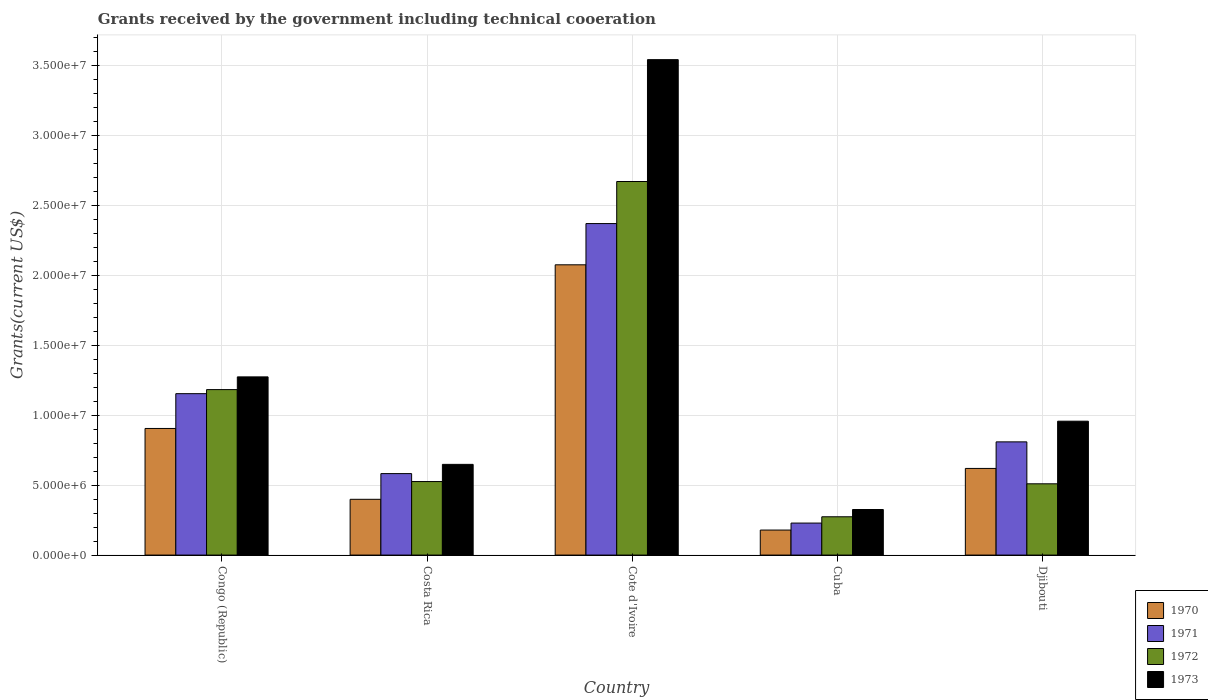How many different coloured bars are there?
Your answer should be very brief. 4. What is the label of the 3rd group of bars from the left?
Provide a succinct answer. Cote d'Ivoire. In how many cases, is the number of bars for a given country not equal to the number of legend labels?
Your response must be concise. 0. What is the total grants received by the government in 1970 in Congo (Republic)?
Provide a short and direct response. 9.06e+06. Across all countries, what is the maximum total grants received by the government in 1972?
Offer a terse response. 2.67e+07. Across all countries, what is the minimum total grants received by the government in 1973?
Offer a very short reply. 3.26e+06. In which country was the total grants received by the government in 1972 maximum?
Ensure brevity in your answer.  Cote d'Ivoire. In which country was the total grants received by the government in 1971 minimum?
Offer a terse response. Cuba. What is the total total grants received by the government in 1972 in the graph?
Keep it short and to the point. 5.17e+07. What is the difference between the total grants received by the government in 1972 in Cote d'Ivoire and that in Djibouti?
Ensure brevity in your answer.  2.16e+07. What is the difference between the total grants received by the government in 1970 in Congo (Republic) and the total grants received by the government in 1972 in Cuba?
Provide a short and direct response. 6.32e+06. What is the average total grants received by the government in 1970 per country?
Your answer should be very brief. 8.36e+06. What is the difference between the total grants received by the government of/in 1970 and total grants received by the government of/in 1972 in Congo (Republic)?
Your response must be concise. -2.78e+06. In how many countries, is the total grants received by the government in 1971 greater than 6000000 US$?
Ensure brevity in your answer.  3. What is the ratio of the total grants received by the government in 1972 in Congo (Republic) to that in Cote d'Ivoire?
Keep it short and to the point. 0.44. Is the total grants received by the government in 1972 in Cuba less than that in Djibouti?
Keep it short and to the point. Yes. Is the difference between the total grants received by the government in 1970 in Cuba and Djibouti greater than the difference between the total grants received by the government in 1972 in Cuba and Djibouti?
Provide a short and direct response. No. What is the difference between the highest and the second highest total grants received by the government in 1970?
Offer a very short reply. 1.17e+07. What is the difference between the highest and the lowest total grants received by the government in 1973?
Keep it short and to the point. 3.22e+07. Is the sum of the total grants received by the government in 1972 in Congo (Republic) and Djibouti greater than the maximum total grants received by the government in 1971 across all countries?
Make the answer very short. No. What does the 3rd bar from the left in Congo (Republic) represents?
Give a very brief answer. 1972. What does the 4th bar from the right in Cote d'Ivoire represents?
Your answer should be compact. 1970. What is the difference between two consecutive major ticks on the Y-axis?
Provide a short and direct response. 5.00e+06. Does the graph contain grids?
Offer a very short reply. Yes. What is the title of the graph?
Make the answer very short. Grants received by the government including technical cooeration. Does "1990" appear as one of the legend labels in the graph?
Provide a short and direct response. No. What is the label or title of the Y-axis?
Your answer should be compact. Grants(current US$). What is the Grants(current US$) of 1970 in Congo (Republic)?
Provide a succinct answer. 9.06e+06. What is the Grants(current US$) of 1971 in Congo (Republic)?
Your answer should be very brief. 1.16e+07. What is the Grants(current US$) of 1972 in Congo (Republic)?
Provide a succinct answer. 1.18e+07. What is the Grants(current US$) of 1973 in Congo (Republic)?
Your answer should be very brief. 1.28e+07. What is the Grants(current US$) of 1970 in Costa Rica?
Make the answer very short. 3.99e+06. What is the Grants(current US$) of 1971 in Costa Rica?
Provide a short and direct response. 5.83e+06. What is the Grants(current US$) of 1972 in Costa Rica?
Provide a short and direct response. 5.26e+06. What is the Grants(current US$) of 1973 in Costa Rica?
Make the answer very short. 6.49e+06. What is the Grants(current US$) in 1970 in Cote d'Ivoire?
Make the answer very short. 2.08e+07. What is the Grants(current US$) of 1971 in Cote d'Ivoire?
Offer a very short reply. 2.37e+07. What is the Grants(current US$) of 1972 in Cote d'Ivoire?
Ensure brevity in your answer.  2.67e+07. What is the Grants(current US$) of 1973 in Cote d'Ivoire?
Provide a short and direct response. 3.54e+07. What is the Grants(current US$) of 1970 in Cuba?
Ensure brevity in your answer.  1.79e+06. What is the Grants(current US$) in 1971 in Cuba?
Your answer should be compact. 2.29e+06. What is the Grants(current US$) of 1972 in Cuba?
Make the answer very short. 2.74e+06. What is the Grants(current US$) of 1973 in Cuba?
Give a very brief answer. 3.26e+06. What is the Grants(current US$) in 1970 in Djibouti?
Provide a short and direct response. 6.20e+06. What is the Grants(current US$) of 1971 in Djibouti?
Provide a short and direct response. 8.10e+06. What is the Grants(current US$) of 1972 in Djibouti?
Offer a terse response. 5.10e+06. What is the Grants(current US$) in 1973 in Djibouti?
Offer a terse response. 9.58e+06. Across all countries, what is the maximum Grants(current US$) of 1970?
Offer a very short reply. 2.08e+07. Across all countries, what is the maximum Grants(current US$) in 1971?
Keep it short and to the point. 2.37e+07. Across all countries, what is the maximum Grants(current US$) in 1972?
Make the answer very short. 2.67e+07. Across all countries, what is the maximum Grants(current US$) in 1973?
Give a very brief answer. 3.54e+07. Across all countries, what is the minimum Grants(current US$) in 1970?
Offer a very short reply. 1.79e+06. Across all countries, what is the minimum Grants(current US$) in 1971?
Offer a terse response. 2.29e+06. Across all countries, what is the minimum Grants(current US$) in 1972?
Your answer should be compact. 2.74e+06. Across all countries, what is the minimum Grants(current US$) in 1973?
Your response must be concise. 3.26e+06. What is the total Grants(current US$) of 1970 in the graph?
Give a very brief answer. 4.18e+07. What is the total Grants(current US$) of 1971 in the graph?
Your answer should be compact. 5.15e+07. What is the total Grants(current US$) of 1972 in the graph?
Make the answer very short. 5.17e+07. What is the total Grants(current US$) of 1973 in the graph?
Offer a terse response. 6.75e+07. What is the difference between the Grants(current US$) in 1970 in Congo (Republic) and that in Costa Rica?
Provide a succinct answer. 5.07e+06. What is the difference between the Grants(current US$) of 1971 in Congo (Republic) and that in Costa Rica?
Provide a succinct answer. 5.72e+06. What is the difference between the Grants(current US$) in 1972 in Congo (Republic) and that in Costa Rica?
Your answer should be very brief. 6.58e+06. What is the difference between the Grants(current US$) of 1973 in Congo (Republic) and that in Costa Rica?
Your answer should be very brief. 6.26e+06. What is the difference between the Grants(current US$) of 1970 in Congo (Republic) and that in Cote d'Ivoire?
Offer a terse response. -1.17e+07. What is the difference between the Grants(current US$) in 1971 in Congo (Republic) and that in Cote d'Ivoire?
Ensure brevity in your answer.  -1.22e+07. What is the difference between the Grants(current US$) in 1972 in Congo (Republic) and that in Cote d'Ivoire?
Provide a short and direct response. -1.49e+07. What is the difference between the Grants(current US$) of 1973 in Congo (Republic) and that in Cote d'Ivoire?
Your answer should be very brief. -2.27e+07. What is the difference between the Grants(current US$) in 1970 in Congo (Republic) and that in Cuba?
Make the answer very short. 7.27e+06. What is the difference between the Grants(current US$) in 1971 in Congo (Republic) and that in Cuba?
Make the answer very short. 9.26e+06. What is the difference between the Grants(current US$) of 1972 in Congo (Republic) and that in Cuba?
Provide a short and direct response. 9.10e+06. What is the difference between the Grants(current US$) of 1973 in Congo (Republic) and that in Cuba?
Make the answer very short. 9.49e+06. What is the difference between the Grants(current US$) of 1970 in Congo (Republic) and that in Djibouti?
Keep it short and to the point. 2.86e+06. What is the difference between the Grants(current US$) in 1971 in Congo (Republic) and that in Djibouti?
Your answer should be compact. 3.45e+06. What is the difference between the Grants(current US$) of 1972 in Congo (Republic) and that in Djibouti?
Your answer should be very brief. 6.74e+06. What is the difference between the Grants(current US$) in 1973 in Congo (Republic) and that in Djibouti?
Your answer should be compact. 3.17e+06. What is the difference between the Grants(current US$) of 1970 in Costa Rica and that in Cote d'Ivoire?
Offer a very short reply. -1.68e+07. What is the difference between the Grants(current US$) in 1971 in Costa Rica and that in Cote d'Ivoire?
Your answer should be compact. -1.79e+07. What is the difference between the Grants(current US$) of 1972 in Costa Rica and that in Cote d'Ivoire?
Provide a short and direct response. -2.15e+07. What is the difference between the Grants(current US$) in 1973 in Costa Rica and that in Cote d'Ivoire?
Your answer should be very brief. -2.90e+07. What is the difference between the Grants(current US$) of 1970 in Costa Rica and that in Cuba?
Your answer should be very brief. 2.20e+06. What is the difference between the Grants(current US$) of 1971 in Costa Rica and that in Cuba?
Your response must be concise. 3.54e+06. What is the difference between the Grants(current US$) of 1972 in Costa Rica and that in Cuba?
Make the answer very short. 2.52e+06. What is the difference between the Grants(current US$) of 1973 in Costa Rica and that in Cuba?
Keep it short and to the point. 3.23e+06. What is the difference between the Grants(current US$) in 1970 in Costa Rica and that in Djibouti?
Give a very brief answer. -2.21e+06. What is the difference between the Grants(current US$) of 1971 in Costa Rica and that in Djibouti?
Your response must be concise. -2.27e+06. What is the difference between the Grants(current US$) in 1973 in Costa Rica and that in Djibouti?
Make the answer very short. -3.09e+06. What is the difference between the Grants(current US$) in 1970 in Cote d'Ivoire and that in Cuba?
Provide a short and direct response. 1.90e+07. What is the difference between the Grants(current US$) of 1971 in Cote d'Ivoire and that in Cuba?
Give a very brief answer. 2.14e+07. What is the difference between the Grants(current US$) in 1972 in Cote d'Ivoire and that in Cuba?
Your response must be concise. 2.40e+07. What is the difference between the Grants(current US$) in 1973 in Cote d'Ivoire and that in Cuba?
Your answer should be very brief. 3.22e+07. What is the difference between the Grants(current US$) of 1970 in Cote d'Ivoire and that in Djibouti?
Give a very brief answer. 1.46e+07. What is the difference between the Grants(current US$) in 1971 in Cote d'Ivoire and that in Djibouti?
Ensure brevity in your answer.  1.56e+07. What is the difference between the Grants(current US$) of 1972 in Cote d'Ivoire and that in Djibouti?
Offer a terse response. 2.16e+07. What is the difference between the Grants(current US$) of 1973 in Cote d'Ivoire and that in Djibouti?
Offer a very short reply. 2.59e+07. What is the difference between the Grants(current US$) of 1970 in Cuba and that in Djibouti?
Keep it short and to the point. -4.41e+06. What is the difference between the Grants(current US$) in 1971 in Cuba and that in Djibouti?
Make the answer very short. -5.81e+06. What is the difference between the Grants(current US$) in 1972 in Cuba and that in Djibouti?
Keep it short and to the point. -2.36e+06. What is the difference between the Grants(current US$) of 1973 in Cuba and that in Djibouti?
Give a very brief answer. -6.32e+06. What is the difference between the Grants(current US$) in 1970 in Congo (Republic) and the Grants(current US$) in 1971 in Costa Rica?
Your answer should be very brief. 3.23e+06. What is the difference between the Grants(current US$) of 1970 in Congo (Republic) and the Grants(current US$) of 1972 in Costa Rica?
Your response must be concise. 3.80e+06. What is the difference between the Grants(current US$) of 1970 in Congo (Republic) and the Grants(current US$) of 1973 in Costa Rica?
Make the answer very short. 2.57e+06. What is the difference between the Grants(current US$) of 1971 in Congo (Republic) and the Grants(current US$) of 1972 in Costa Rica?
Provide a succinct answer. 6.29e+06. What is the difference between the Grants(current US$) of 1971 in Congo (Republic) and the Grants(current US$) of 1973 in Costa Rica?
Offer a terse response. 5.06e+06. What is the difference between the Grants(current US$) of 1972 in Congo (Republic) and the Grants(current US$) of 1973 in Costa Rica?
Your answer should be very brief. 5.35e+06. What is the difference between the Grants(current US$) in 1970 in Congo (Republic) and the Grants(current US$) in 1971 in Cote d'Ivoire?
Make the answer very short. -1.47e+07. What is the difference between the Grants(current US$) of 1970 in Congo (Republic) and the Grants(current US$) of 1972 in Cote d'Ivoire?
Offer a terse response. -1.77e+07. What is the difference between the Grants(current US$) in 1970 in Congo (Republic) and the Grants(current US$) in 1973 in Cote d'Ivoire?
Keep it short and to the point. -2.64e+07. What is the difference between the Grants(current US$) in 1971 in Congo (Republic) and the Grants(current US$) in 1972 in Cote d'Ivoire?
Ensure brevity in your answer.  -1.52e+07. What is the difference between the Grants(current US$) in 1971 in Congo (Republic) and the Grants(current US$) in 1973 in Cote d'Ivoire?
Your answer should be compact. -2.39e+07. What is the difference between the Grants(current US$) of 1972 in Congo (Republic) and the Grants(current US$) of 1973 in Cote d'Ivoire?
Your response must be concise. -2.36e+07. What is the difference between the Grants(current US$) of 1970 in Congo (Republic) and the Grants(current US$) of 1971 in Cuba?
Provide a short and direct response. 6.77e+06. What is the difference between the Grants(current US$) of 1970 in Congo (Republic) and the Grants(current US$) of 1972 in Cuba?
Your answer should be very brief. 6.32e+06. What is the difference between the Grants(current US$) of 1970 in Congo (Republic) and the Grants(current US$) of 1973 in Cuba?
Make the answer very short. 5.80e+06. What is the difference between the Grants(current US$) of 1971 in Congo (Republic) and the Grants(current US$) of 1972 in Cuba?
Offer a terse response. 8.81e+06. What is the difference between the Grants(current US$) of 1971 in Congo (Republic) and the Grants(current US$) of 1973 in Cuba?
Make the answer very short. 8.29e+06. What is the difference between the Grants(current US$) in 1972 in Congo (Republic) and the Grants(current US$) in 1973 in Cuba?
Your answer should be compact. 8.58e+06. What is the difference between the Grants(current US$) in 1970 in Congo (Republic) and the Grants(current US$) in 1971 in Djibouti?
Give a very brief answer. 9.60e+05. What is the difference between the Grants(current US$) of 1970 in Congo (Republic) and the Grants(current US$) of 1972 in Djibouti?
Your answer should be compact. 3.96e+06. What is the difference between the Grants(current US$) in 1970 in Congo (Republic) and the Grants(current US$) in 1973 in Djibouti?
Your answer should be compact. -5.20e+05. What is the difference between the Grants(current US$) in 1971 in Congo (Republic) and the Grants(current US$) in 1972 in Djibouti?
Provide a succinct answer. 6.45e+06. What is the difference between the Grants(current US$) of 1971 in Congo (Republic) and the Grants(current US$) of 1973 in Djibouti?
Give a very brief answer. 1.97e+06. What is the difference between the Grants(current US$) in 1972 in Congo (Republic) and the Grants(current US$) in 1973 in Djibouti?
Your answer should be very brief. 2.26e+06. What is the difference between the Grants(current US$) in 1970 in Costa Rica and the Grants(current US$) in 1971 in Cote d'Ivoire?
Ensure brevity in your answer.  -1.97e+07. What is the difference between the Grants(current US$) of 1970 in Costa Rica and the Grants(current US$) of 1972 in Cote d'Ivoire?
Offer a very short reply. -2.27e+07. What is the difference between the Grants(current US$) in 1970 in Costa Rica and the Grants(current US$) in 1973 in Cote d'Ivoire?
Provide a short and direct response. -3.15e+07. What is the difference between the Grants(current US$) in 1971 in Costa Rica and the Grants(current US$) in 1972 in Cote d'Ivoire?
Provide a succinct answer. -2.09e+07. What is the difference between the Grants(current US$) of 1971 in Costa Rica and the Grants(current US$) of 1973 in Cote d'Ivoire?
Your response must be concise. -2.96e+07. What is the difference between the Grants(current US$) in 1972 in Costa Rica and the Grants(current US$) in 1973 in Cote d'Ivoire?
Provide a succinct answer. -3.02e+07. What is the difference between the Grants(current US$) in 1970 in Costa Rica and the Grants(current US$) in 1971 in Cuba?
Make the answer very short. 1.70e+06. What is the difference between the Grants(current US$) of 1970 in Costa Rica and the Grants(current US$) of 1972 in Cuba?
Your answer should be very brief. 1.25e+06. What is the difference between the Grants(current US$) in 1970 in Costa Rica and the Grants(current US$) in 1973 in Cuba?
Keep it short and to the point. 7.30e+05. What is the difference between the Grants(current US$) of 1971 in Costa Rica and the Grants(current US$) of 1972 in Cuba?
Your answer should be compact. 3.09e+06. What is the difference between the Grants(current US$) in 1971 in Costa Rica and the Grants(current US$) in 1973 in Cuba?
Your answer should be very brief. 2.57e+06. What is the difference between the Grants(current US$) of 1972 in Costa Rica and the Grants(current US$) of 1973 in Cuba?
Offer a terse response. 2.00e+06. What is the difference between the Grants(current US$) in 1970 in Costa Rica and the Grants(current US$) in 1971 in Djibouti?
Offer a terse response. -4.11e+06. What is the difference between the Grants(current US$) in 1970 in Costa Rica and the Grants(current US$) in 1972 in Djibouti?
Give a very brief answer. -1.11e+06. What is the difference between the Grants(current US$) in 1970 in Costa Rica and the Grants(current US$) in 1973 in Djibouti?
Offer a terse response. -5.59e+06. What is the difference between the Grants(current US$) of 1971 in Costa Rica and the Grants(current US$) of 1972 in Djibouti?
Ensure brevity in your answer.  7.30e+05. What is the difference between the Grants(current US$) in 1971 in Costa Rica and the Grants(current US$) in 1973 in Djibouti?
Give a very brief answer. -3.75e+06. What is the difference between the Grants(current US$) in 1972 in Costa Rica and the Grants(current US$) in 1973 in Djibouti?
Provide a succinct answer. -4.32e+06. What is the difference between the Grants(current US$) of 1970 in Cote d'Ivoire and the Grants(current US$) of 1971 in Cuba?
Provide a succinct answer. 1.85e+07. What is the difference between the Grants(current US$) in 1970 in Cote d'Ivoire and the Grants(current US$) in 1972 in Cuba?
Give a very brief answer. 1.80e+07. What is the difference between the Grants(current US$) in 1970 in Cote d'Ivoire and the Grants(current US$) in 1973 in Cuba?
Your answer should be very brief. 1.75e+07. What is the difference between the Grants(current US$) of 1971 in Cote d'Ivoire and the Grants(current US$) of 1972 in Cuba?
Offer a terse response. 2.10e+07. What is the difference between the Grants(current US$) of 1971 in Cote d'Ivoire and the Grants(current US$) of 1973 in Cuba?
Your answer should be very brief. 2.05e+07. What is the difference between the Grants(current US$) in 1972 in Cote d'Ivoire and the Grants(current US$) in 1973 in Cuba?
Provide a short and direct response. 2.35e+07. What is the difference between the Grants(current US$) in 1970 in Cote d'Ivoire and the Grants(current US$) in 1971 in Djibouti?
Make the answer very short. 1.27e+07. What is the difference between the Grants(current US$) of 1970 in Cote d'Ivoire and the Grants(current US$) of 1972 in Djibouti?
Your response must be concise. 1.57e+07. What is the difference between the Grants(current US$) in 1970 in Cote d'Ivoire and the Grants(current US$) in 1973 in Djibouti?
Keep it short and to the point. 1.12e+07. What is the difference between the Grants(current US$) of 1971 in Cote d'Ivoire and the Grants(current US$) of 1972 in Djibouti?
Offer a terse response. 1.86e+07. What is the difference between the Grants(current US$) of 1971 in Cote d'Ivoire and the Grants(current US$) of 1973 in Djibouti?
Provide a succinct answer. 1.41e+07. What is the difference between the Grants(current US$) of 1972 in Cote d'Ivoire and the Grants(current US$) of 1973 in Djibouti?
Keep it short and to the point. 1.72e+07. What is the difference between the Grants(current US$) of 1970 in Cuba and the Grants(current US$) of 1971 in Djibouti?
Keep it short and to the point. -6.31e+06. What is the difference between the Grants(current US$) of 1970 in Cuba and the Grants(current US$) of 1972 in Djibouti?
Make the answer very short. -3.31e+06. What is the difference between the Grants(current US$) of 1970 in Cuba and the Grants(current US$) of 1973 in Djibouti?
Offer a terse response. -7.79e+06. What is the difference between the Grants(current US$) in 1971 in Cuba and the Grants(current US$) in 1972 in Djibouti?
Your answer should be compact. -2.81e+06. What is the difference between the Grants(current US$) of 1971 in Cuba and the Grants(current US$) of 1973 in Djibouti?
Give a very brief answer. -7.29e+06. What is the difference between the Grants(current US$) of 1972 in Cuba and the Grants(current US$) of 1973 in Djibouti?
Your response must be concise. -6.84e+06. What is the average Grants(current US$) in 1970 per country?
Keep it short and to the point. 8.36e+06. What is the average Grants(current US$) of 1971 per country?
Offer a very short reply. 1.03e+07. What is the average Grants(current US$) in 1972 per country?
Provide a short and direct response. 1.03e+07. What is the average Grants(current US$) in 1973 per country?
Offer a very short reply. 1.35e+07. What is the difference between the Grants(current US$) in 1970 and Grants(current US$) in 1971 in Congo (Republic)?
Your response must be concise. -2.49e+06. What is the difference between the Grants(current US$) in 1970 and Grants(current US$) in 1972 in Congo (Republic)?
Make the answer very short. -2.78e+06. What is the difference between the Grants(current US$) of 1970 and Grants(current US$) of 1973 in Congo (Republic)?
Your answer should be very brief. -3.69e+06. What is the difference between the Grants(current US$) in 1971 and Grants(current US$) in 1973 in Congo (Republic)?
Provide a short and direct response. -1.20e+06. What is the difference between the Grants(current US$) in 1972 and Grants(current US$) in 1973 in Congo (Republic)?
Provide a succinct answer. -9.10e+05. What is the difference between the Grants(current US$) in 1970 and Grants(current US$) in 1971 in Costa Rica?
Offer a very short reply. -1.84e+06. What is the difference between the Grants(current US$) of 1970 and Grants(current US$) of 1972 in Costa Rica?
Keep it short and to the point. -1.27e+06. What is the difference between the Grants(current US$) of 1970 and Grants(current US$) of 1973 in Costa Rica?
Offer a terse response. -2.50e+06. What is the difference between the Grants(current US$) in 1971 and Grants(current US$) in 1972 in Costa Rica?
Keep it short and to the point. 5.70e+05. What is the difference between the Grants(current US$) of 1971 and Grants(current US$) of 1973 in Costa Rica?
Offer a very short reply. -6.60e+05. What is the difference between the Grants(current US$) in 1972 and Grants(current US$) in 1973 in Costa Rica?
Your answer should be very brief. -1.23e+06. What is the difference between the Grants(current US$) in 1970 and Grants(current US$) in 1971 in Cote d'Ivoire?
Your answer should be compact. -2.95e+06. What is the difference between the Grants(current US$) in 1970 and Grants(current US$) in 1972 in Cote d'Ivoire?
Offer a very short reply. -5.96e+06. What is the difference between the Grants(current US$) in 1970 and Grants(current US$) in 1973 in Cote d'Ivoire?
Make the answer very short. -1.47e+07. What is the difference between the Grants(current US$) in 1971 and Grants(current US$) in 1972 in Cote d'Ivoire?
Your answer should be compact. -3.01e+06. What is the difference between the Grants(current US$) of 1971 and Grants(current US$) of 1973 in Cote d'Ivoire?
Keep it short and to the point. -1.17e+07. What is the difference between the Grants(current US$) in 1972 and Grants(current US$) in 1973 in Cote d'Ivoire?
Your response must be concise. -8.72e+06. What is the difference between the Grants(current US$) in 1970 and Grants(current US$) in 1971 in Cuba?
Your response must be concise. -5.00e+05. What is the difference between the Grants(current US$) in 1970 and Grants(current US$) in 1972 in Cuba?
Provide a succinct answer. -9.50e+05. What is the difference between the Grants(current US$) in 1970 and Grants(current US$) in 1973 in Cuba?
Keep it short and to the point. -1.47e+06. What is the difference between the Grants(current US$) in 1971 and Grants(current US$) in 1972 in Cuba?
Make the answer very short. -4.50e+05. What is the difference between the Grants(current US$) in 1971 and Grants(current US$) in 1973 in Cuba?
Your response must be concise. -9.70e+05. What is the difference between the Grants(current US$) in 1972 and Grants(current US$) in 1973 in Cuba?
Offer a very short reply. -5.20e+05. What is the difference between the Grants(current US$) in 1970 and Grants(current US$) in 1971 in Djibouti?
Provide a succinct answer. -1.90e+06. What is the difference between the Grants(current US$) in 1970 and Grants(current US$) in 1972 in Djibouti?
Give a very brief answer. 1.10e+06. What is the difference between the Grants(current US$) in 1970 and Grants(current US$) in 1973 in Djibouti?
Your answer should be compact. -3.38e+06. What is the difference between the Grants(current US$) in 1971 and Grants(current US$) in 1972 in Djibouti?
Keep it short and to the point. 3.00e+06. What is the difference between the Grants(current US$) of 1971 and Grants(current US$) of 1973 in Djibouti?
Make the answer very short. -1.48e+06. What is the difference between the Grants(current US$) of 1972 and Grants(current US$) of 1973 in Djibouti?
Your response must be concise. -4.48e+06. What is the ratio of the Grants(current US$) of 1970 in Congo (Republic) to that in Costa Rica?
Keep it short and to the point. 2.27. What is the ratio of the Grants(current US$) of 1971 in Congo (Republic) to that in Costa Rica?
Your answer should be compact. 1.98. What is the ratio of the Grants(current US$) in 1972 in Congo (Republic) to that in Costa Rica?
Provide a short and direct response. 2.25. What is the ratio of the Grants(current US$) in 1973 in Congo (Republic) to that in Costa Rica?
Your answer should be very brief. 1.96. What is the ratio of the Grants(current US$) of 1970 in Congo (Republic) to that in Cote d'Ivoire?
Offer a terse response. 0.44. What is the ratio of the Grants(current US$) of 1971 in Congo (Republic) to that in Cote d'Ivoire?
Offer a terse response. 0.49. What is the ratio of the Grants(current US$) in 1972 in Congo (Republic) to that in Cote d'Ivoire?
Keep it short and to the point. 0.44. What is the ratio of the Grants(current US$) in 1973 in Congo (Republic) to that in Cote d'Ivoire?
Ensure brevity in your answer.  0.36. What is the ratio of the Grants(current US$) in 1970 in Congo (Republic) to that in Cuba?
Your answer should be very brief. 5.06. What is the ratio of the Grants(current US$) of 1971 in Congo (Republic) to that in Cuba?
Offer a terse response. 5.04. What is the ratio of the Grants(current US$) of 1972 in Congo (Republic) to that in Cuba?
Your response must be concise. 4.32. What is the ratio of the Grants(current US$) of 1973 in Congo (Republic) to that in Cuba?
Your answer should be compact. 3.91. What is the ratio of the Grants(current US$) in 1970 in Congo (Republic) to that in Djibouti?
Provide a short and direct response. 1.46. What is the ratio of the Grants(current US$) in 1971 in Congo (Republic) to that in Djibouti?
Your response must be concise. 1.43. What is the ratio of the Grants(current US$) in 1972 in Congo (Republic) to that in Djibouti?
Give a very brief answer. 2.32. What is the ratio of the Grants(current US$) in 1973 in Congo (Republic) to that in Djibouti?
Provide a succinct answer. 1.33. What is the ratio of the Grants(current US$) of 1970 in Costa Rica to that in Cote d'Ivoire?
Your answer should be very brief. 0.19. What is the ratio of the Grants(current US$) in 1971 in Costa Rica to that in Cote d'Ivoire?
Provide a short and direct response. 0.25. What is the ratio of the Grants(current US$) of 1972 in Costa Rica to that in Cote d'Ivoire?
Give a very brief answer. 0.2. What is the ratio of the Grants(current US$) of 1973 in Costa Rica to that in Cote d'Ivoire?
Keep it short and to the point. 0.18. What is the ratio of the Grants(current US$) of 1970 in Costa Rica to that in Cuba?
Make the answer very short. 2.23. What is the ratio of the Grants(current US$) of 1971 in Costa Rica to that in Cuba?
Your answer should be compact. 2.55. What is the ratio of the Grants(current US$) in 1972 in Costa Rica to that in Cuba?
Your answer should be compact. 1.92. What is the ratio of the Grants(current US$) of 1973 in Costa Rica to that in Cuba?
Your answer should be compact. 1.99. What is the ratio of the Grants(current US$) of 1970 in Costa Rica to that in Djibouti?
Your answer should be compact. 0.64. What is the ratio of the Grants(current US$) in 1971 in Costa Rica to that in Djibouti?
Offer a very short reply. 0.72. What is the ratio of the Grants(current US$) of 1972 in Costa Rica to that in Djibouti?
Offer a terse response. 1.03. What is the ratio of the Grants(current US$) of 1973 in Costa Rica to that in Djibouti?
Make the answer very short. 0.68. What is the ratio of the Grants(current US$) of 1970 in Cote d'Ivoire to that in Cuba?
Offer a terse response. 11.6. What is the ratio of the Grants(current US$) in 1971 in Cote d'Ivoire to that in Cuba?
Your answer should be compact. 10.36. What is the ratio of the Grants(current US$) in 1972 in Cote d'Ivoire to that in Cuba?
Offer a very short reply. 9.76. What is the ratio of the Grants(current US$) of 1973 in Cote d'Ivoire to that in Cuba?
Make the answer very short. 10.87. What is the ratio of the Grants(current US$) of 1970 in Cote d'Ivoire to that in Djibouti?
Your answer should be very brief. 3.35. What is the ratio of the Grants(current US$) of 1971 in Cote d'Ivoire to that in Djibouti?
Give a very brief answer. 2.93. What is the ratio of the Grants(current US$) of 1972 in Cote d'Ivoire to that in Djibouti?
Provide a short and direct response. 5.24. What is the ratio of the Grants(current US$) in 1973 in Cote d'Ivoire to that in Djibouti?
Ensure brevity in your answer.  3.7. What is the ratio of the Grants(current US$) in 1970 in Cuba to that in Djibouti?
Make the answer very short. 0.29. What is the ratio of the Grants(current US$) of 1971 in Cuba to that in Djibouti?
Offer a terse response. 0.28. What is the ratio of the Grants(current US$) in 1972 in Cuba to that in Djibouti?
Offer a terse response. 0.54. What is the ratio of the Grants(current US$) in 1973 in Cuba to that in Djibouti?
Offer a terse response. 0.34. What is the difference between the highest and the second highest Grants(current US$) of 1970?
Your response must be concise. 1.17e+07. What is the difference between the highest and the second highest Grants(current US$) of 1971?
Offer a terse response. 1.22e+07. What is the difference between the highest and the second highest Grants(current US$) of 1972?
Your answer should be compact. 1.49e+07. What is the difference between the highest and the second highest Grants(current US$) of 1973?
Offer a very short reply. 2.27e+07. What is the difference between the highest and the lowest Grants(current US$) in 1970?
Ensure brevity in your answer.  1.90e+07. What is the difference between the highest and the lowest Grants(current US$) in 1971?
Make the answer very short. 2.14e+07. What is the difference between the highest and the lowest Grants(current US$) in 1972?
Keep it short and to the point. 2.40e+07. What is the difference between the highest and the lowest Grants(current US$) of 1973?
Your answer should be compact. 3.22e+07. 